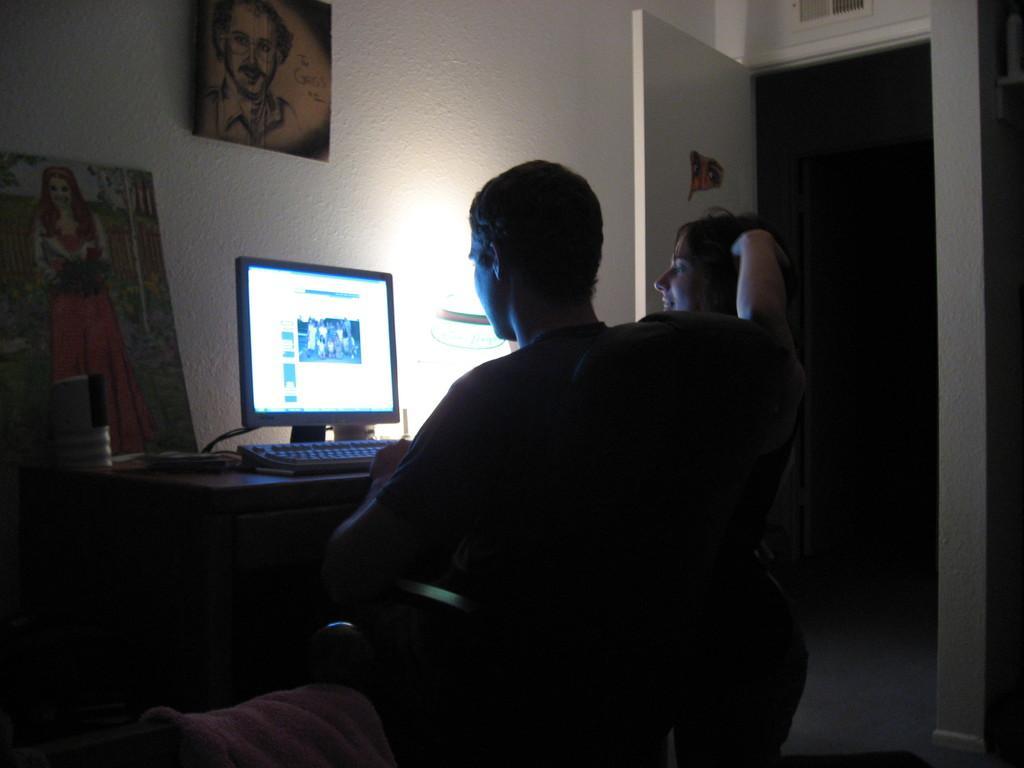Can you describe this image briefly? In this picture there is a man who is sitting on the chair. There is a woman who is sitting on the chair. Both are looking into the screen. There is an image of a man on the wall. To the left side,there is an image of a woman. There is a door which is white in color. There is towel which is pink in color. 